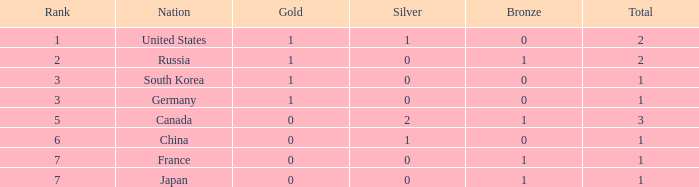Which bronze possesses a rank of 3, and a silver greater than 0? None. 